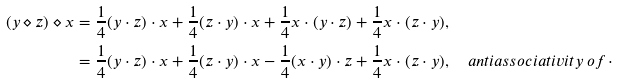<formula> <loc_0><loc_0><loc_500><loc_500>( y \diamond z ) \diamond x & = \frac { 1 } { 4 } ( y \cdot z ) \cdot x + \frac { 1 } { 4 } ( z \cdot y ) \cdot x + \frac { 1 } { 4 } x \cdot ( y \cdot z ) + \frac { 1 } { 4 } x \cdot ( z \cdot y ) , \\ & = \frac { 1 } { 4 } ( y \cdot z ) \cdot x + \frac { 1 } { 4 } ( z \cdot y ) \cdot x - \frac { 1 } { 4 } ( x \cdot y ) \cdot z + \frac { 1 } { 4 } x \cdot ( z \cdot y ) , \quad a n t i a s s o c i a t i v i t y \, o f \, \cdot</formula> 